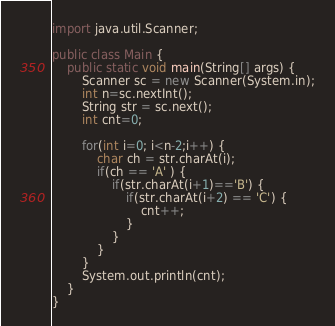<code> <loc_0><loc_0><loc_500><loc_500><_Java_>import java.util.Scanner;

public class Main {
	public static void main(String[] args) {
		Scanner sc = new Scanner(System.in);
		int n=sc.nextInt();
		String str = sc.next();
		int cnt=0;

		for(int i=0; i<n-2;i++) {
			char ch = str.charAt(i);
			if(ch == 'A' ) {
				if(str.charAt(i+1)=='B') {
					if(str.charAt(i+2) == 'C') {
						cnt++;
					}
				}
			}
		}
		System.out.println(cnt);
	}
}</code> 